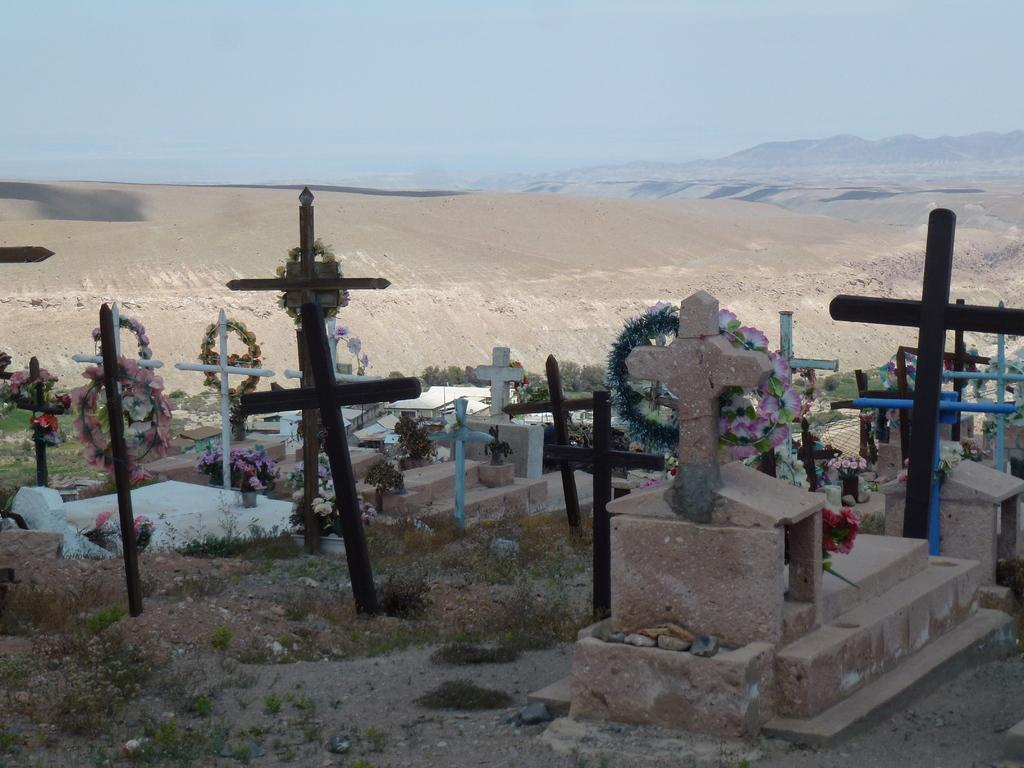What is the main setting of the image? There is a graveyard in the image. What can be seen on the graves in the graveyard? The graveyard has cross symbols. What type of dog can be seen playing with a rule in the image? There is no dog or rule present in the image; it features a graveyard with cross symbols on the graves. What type of wound is visible on the graves in the image? There are no wounds visible on the graves in the image; it only features cross symbols. 